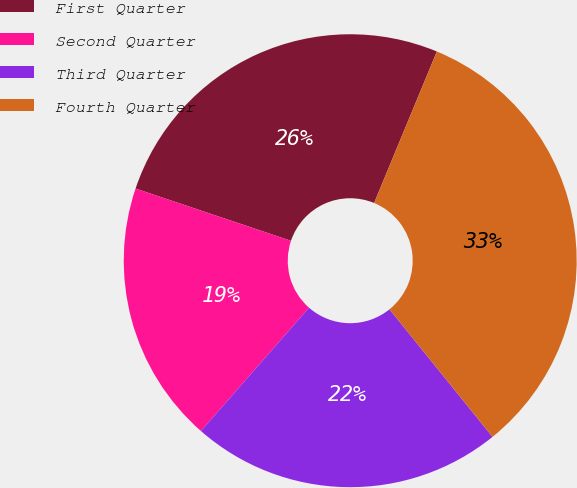Convert chart. <chart><loc_0><loc_0><loc_500><loc_500><pie_chart><fcel>First Quarter<fcel>Second Quarter<fcel>Third Quarter<fcel>Fourth Quarter<nl><fcel>26.09%<fcel>18.71%<fcel>22.27%<fcel>32.94%<nl></chart> 